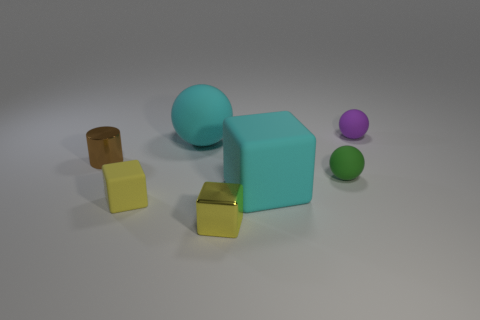Subtract all small matte spheres. How many spheres are left? 1 Add 1 small green matte things. How many objects exist? 8 Subtract all green balls. How many balls are left? 2 Subtract all blocks. How many objects are left? 4 Subtract all brown cubes. Subtract all red cylinders. How many cubes are left? 3 Subtract all yellow cubes. How many red spheres are left? 0 Subtract all gray rubber cylinders. Subtract all brown cylinders. How many objects are left? 6 Add 3 tiny purple rubber spheres. How many tiny purple rubber spheres are left? 4 Add 4 big matte balls. How many big matte balls exist? 5 Subtract 1 green balls. How many objects are left? 6 